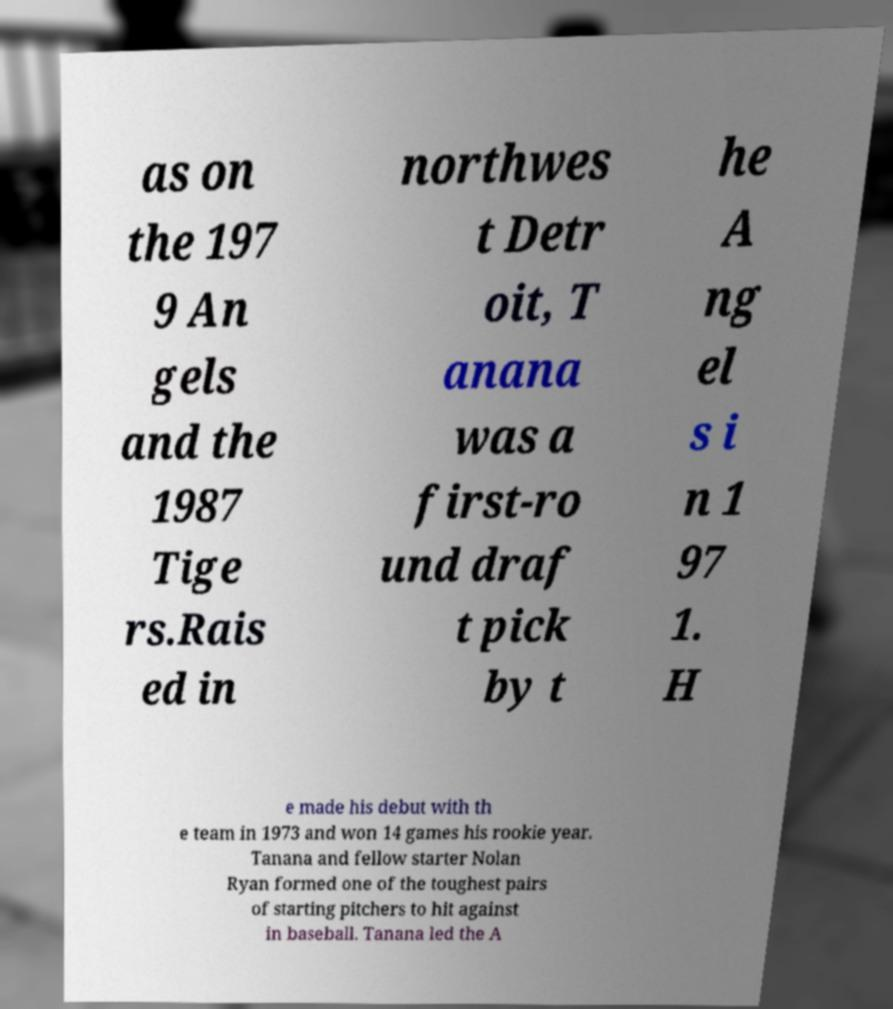Please identify and transcribe the text found in this image. as on the 197 9 An gels and the 1987 Tige rs.Rais ed in northwes t Detr oit, T anana was a first-ro und draf t pick by t he A ng el s i n 1 97 1. H e made his debut with th e team in 1973 and won 14 games his rookie year. Tanana and fellow starter Nolan Ryan formed one of the toughest pairs of starting pitchers to hit against in baseball. Tanana led the A 